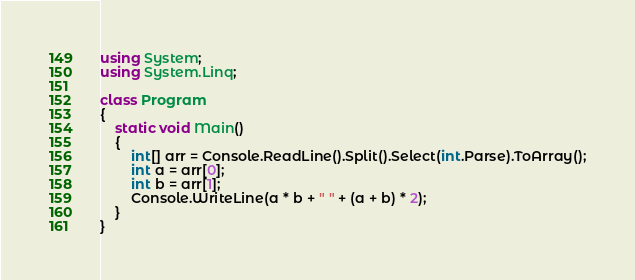<code> <loc_0><loc_0><loc_500><loc_500><_C#_>using System;
using System.Linq;

class Program
{
    static void Main()
    {
        int[] arr = Console.ReadLine().Split().Select(int.Parse).ToArray();
        int a = arr[0];
        int b = arr[1];
        Console.WriteLine(a * b + " " + (a + b) * 2);
    }
}
</code> 